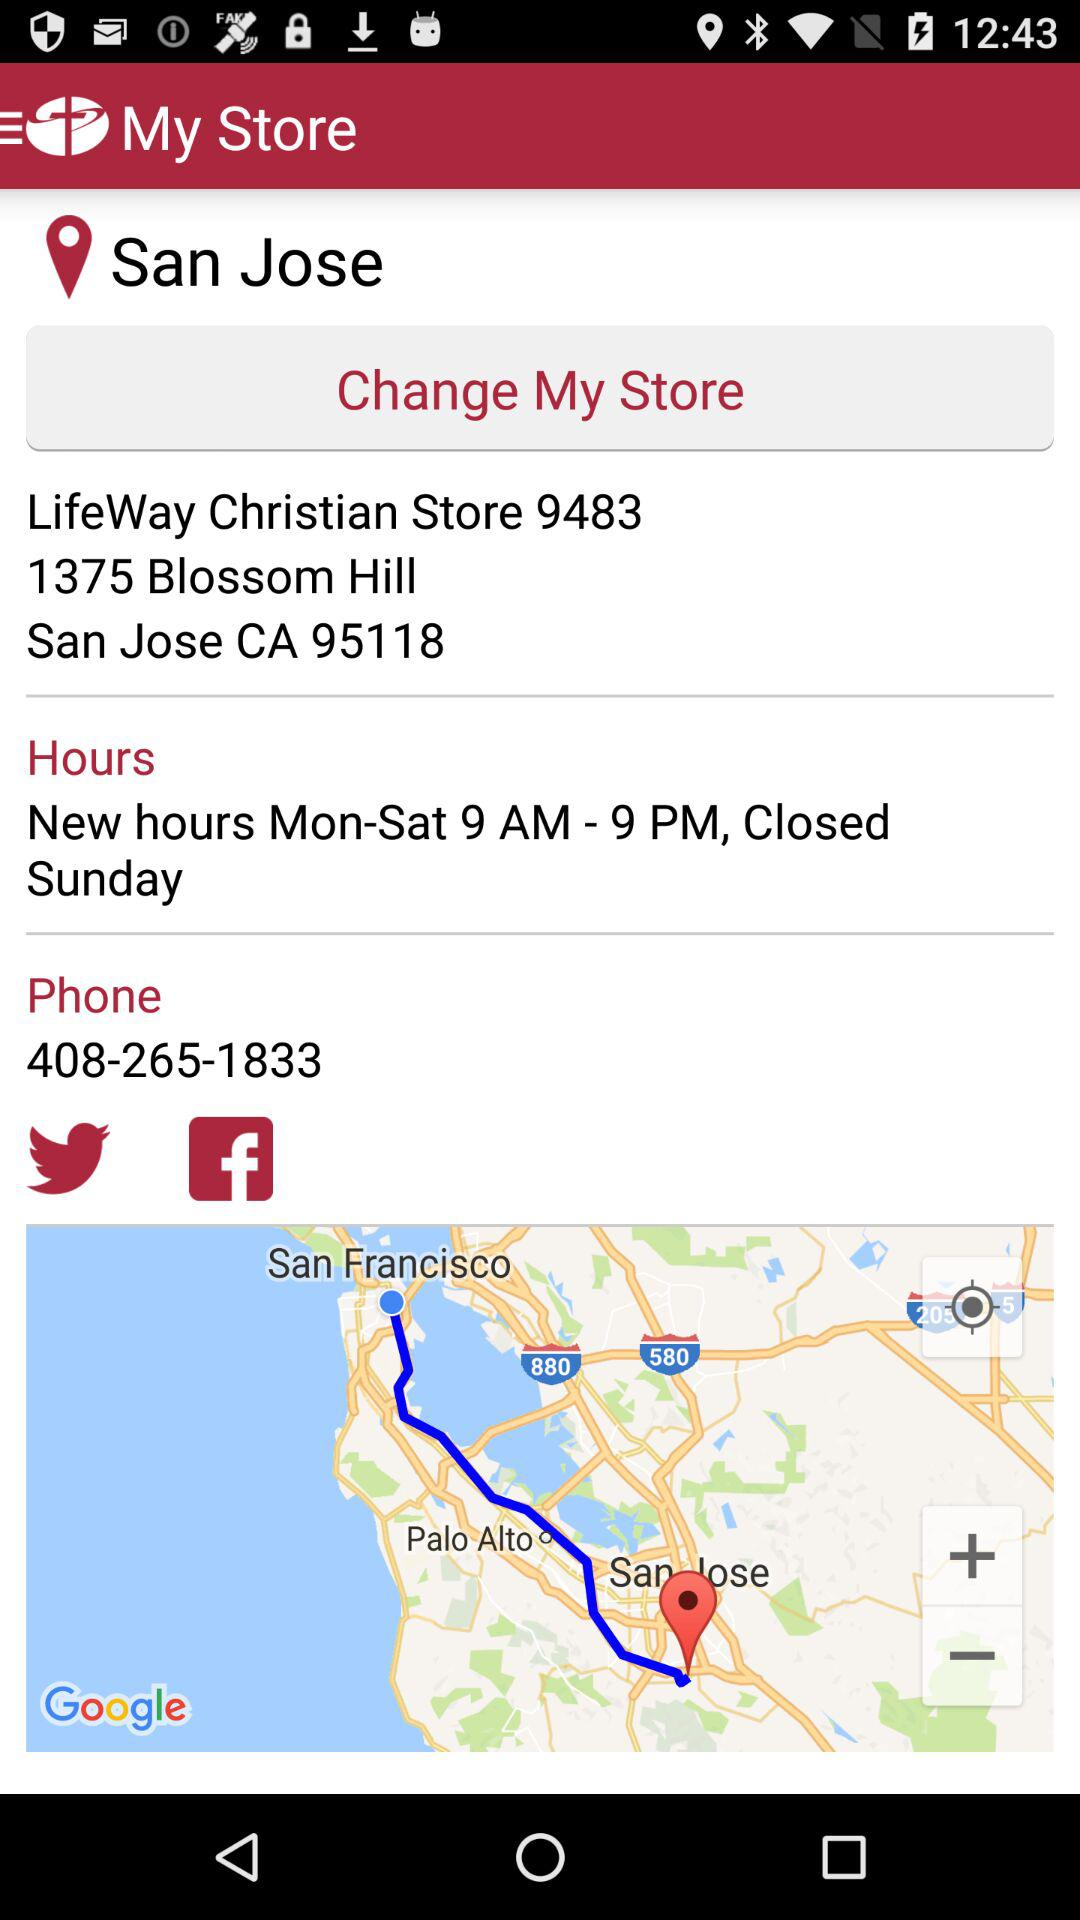What is the store location given? The store location is LifeWay Christian Store 9483, 1375 Blossom Hill, San Jose, CA 95118. 